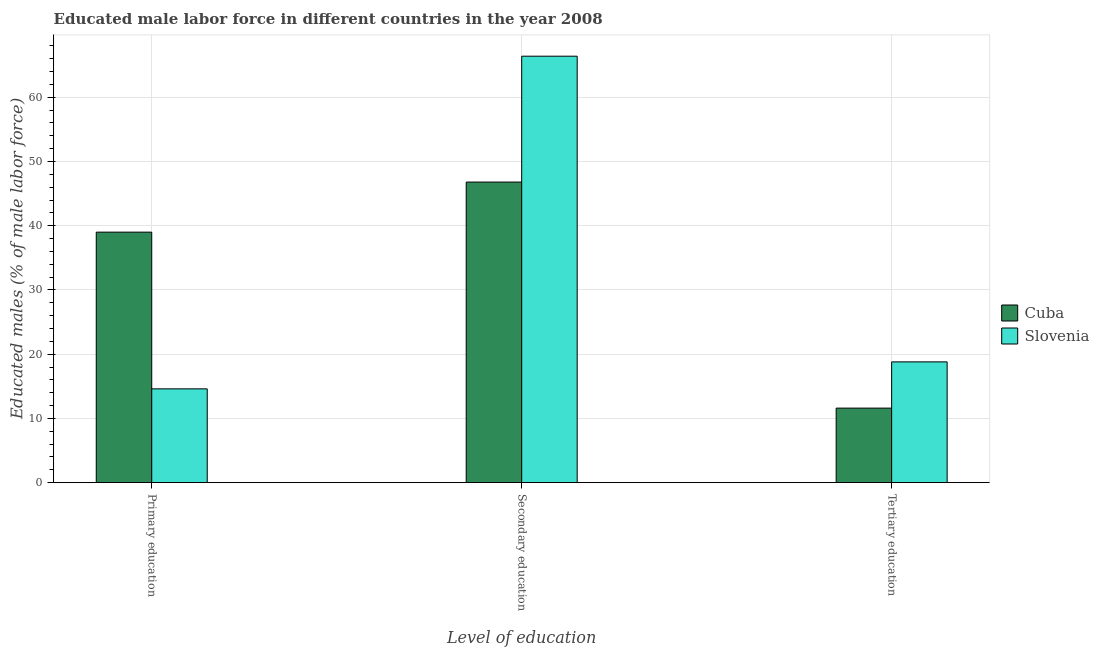How many different coloured bars are there?
Provide a succinct answer. 2. Are the number of bars on each tick of the X-axis equal?
Provide a short and direct response. Yes. How many bars are there on the 2nd tick from the left?
Provide a succinct answer. 2. What is the label of the 1st group of bars from the left?
Offer a very short reply. Primary education. What is the percentage of male labor force who received tertiary education in Cuba?
Give a very brief answer. 11.6. Across all countries, what is the maximum percentage of male labor force who received secondary education?
Make the answer very short. 66.4. Across all countries, what is the minimum percentage of male labor force who received primary education?
Keep it short and to the point. 14.6. In which country was the percentage of male labor force who received tertiary education maximum?
Provide a succinct answer. Slovenia. In which country was the percentage of male labor force who received secondary education minimum?
Provide a short and direct response. Cuba. What is the total percentage of male labor force who received tertiary education in the graph?
Give a very brief answer. 30.4. What is the difference between the percentage of male labor force who received tertiary education in Slovenia and that in Cuba?
Give a very brief answer. 7.2. What is the difference between the percentage of male labor force who received primary education in Slovenia and the percentage of male labor force who received secondary education in Cuba?
Your answer should be very brief. -32.2. What is the average percentage of male labor force who received secondary education per country?
Make the answer very short. 56.6. What is the difference between the percentage of male labor force who received secondary education and percentage of male labor force who received primary education in Cuba?
Your response must be concise. 7.8. What is the ratio of the percentage of male labor force who received secondary education in Slovenia to that in Cuba?
Your answer should be compact. 1.42. Is the percentage of male labor force who received secondary education in Slovenia less than that in Cuba?
Your answer should be very brief. No. What is the difference between the highest and the second highest percentage of male labor force who received secondary education?
Ensure brevity in your answer.  19.6. What is the difference between the highest and the lowest percentage of male labor force who received secondary education?
Keep it short and to the point. 19.6. Is the sum of the percentage of male labor force who received secondary education in Cuba and Slovenia greater than the maximum percentage of male labor force who received tertiary education across all countries?
Your answer should be compact. Yes. What does the 1st bar from the left in Tertiary education represents?
Your answer should be very brief. Cuba. What does the 2nd bar from the right in Tertiary education represents?
Give a very brief answer. Cuba. Is it the case that in every country, the sum of the percentage of male labor force who received primary education and percentage of male labor force who received secondary education is greater than the percentage of male labor force who received tertiary education?
Make the answer very short. Yes. Are all the bars in the graph horizontal?
Your response must be concise. No. How many countries are there in the graph?
Keep it short and to the point. 2. What is the difference between two consecutive major ticks on the Y-axis?
Ensure brevity in your answer.  10. Where does the legend appear in the graph?
Provide a short and direct response. Center right. How are the legend labels stacked?
Your response must be concise. Vertical. What is the title of the graph?
Your response must be concise. Educated male labor force in different countries in the year 2008. What is the label or title of the X-axis?
Provide a short and direct response. Level of education. What is the label or title of the Y-axis?
Ensure brevity in your answer.  Educated males (% of male labor force). What is the Educated males (% of male labor force) in Slovenia in Primary education?
Provide a short and direct response. 14.6. What is the Educated males (% of male labor force) in Cuba in Secondary education?
Offer a terse response. 46.8. What is the Educated males (% of male labor force) of Slovenia in Secondary education?
Offer a terse response. 66.4. What is the Educated males (% of male labor force) of Cuba in Tertiary education?
Offer a very short reply. 11.6. What is the Educated males (% of male labor force) in Slovenia in Tertiary education?
Provide a succinct answer. 18.8. Across all Level of education, what is the maximum Educated males (% of male labor force) in Cuba?
Ensure brevity in your answer.  46.8. Across all Level of education, what is the maximum Educated males (% of male labor force) in Slovenia?
Your answer should be compact. 66.4. Across all Level of education, what is the minimum Educated males (% of male labor force) in Cuba?
Ensure brevity in your answer.  11.6. Across all Level of education, what is the minimum Educated males (% of male labor force) of Slovenia?
Your answer should be compact. 14.6. What is the total Educated males (% of male labor force) in Cuba in the graph?
Make the answer very short. 97.4. What is the total Educated males (% of male labor force) of Slovenia in the graph?
Provide a succinct answer. 99.8. What is the difference between the Educated males (% of male labor force) in Slovenia in Primary education and that in Secondary education?
Offer a terse response. -51.8. What is the difference between the Educated males (% of male labor force) of Cuba in Primary education and that in Tertiary education?
Your response must be concise. 27.4. What is the difference between the Educated males (% of male labor force) of Cuba in Secondary education and that in Tertiary education?
Give a very brief answer. 35.2. What is the difference between the Educated males (% of male labor force) in Slovenia in Secondary education and that in Tertiary education?
Make the answer very short. 47.6. What is the difference between the Educated males (% of male labor force) in Cuba in Primary education and the Educated males (% of male labor force) in Slovenia in Secondary education?
Your answer should be very brief. -27.4. What is the difference between the Educated males (% of male labor force) in Cuba in Primary education and the Educated males (% of male labor force) in Slovenia in Tertiary education?
Offer a very short reply. 20.2. What is the difference between the Educated males (% of male labor force) of Cuba in Secondary education and the Educated males (% of male labor force) of Slovenia in Tertiary education?
Provide a short and direct response. 28. What is the average Educated males (% of male labor force) in Cuba per Level of education?
Give a very brief answer. 32.47. What is the average Educated males (% of male labor force) of Slovenia per Level of education?
Offer a terse response. 33.27. What is the difference between the Educated males (% of male labor force) in Cuba and Educated males (% of male labor force) in Slovenia in Primary education?
Ensure brevity in your answer.  24.4. What is the difference between the Educated males (% of male labor force) of Cuba and Educated males (% of male labor force) of Slovenia in Secondary education?
Your response must be concise. -19.6. What is the difference between the Educated males (% of male labor force) of Cuba and Educated males (% of male labor force) of Slovenia in Tertiary education?
Offer a very short reply. -7.2. What is the ratio of the Educated males (% of male labor force) in Slovenia in Primary education to that in Secondary education?
Give a very brief answer. 0.22. What is the ratio of the Educated males (% of male labor force) in Cuba in Primary education to that in Tertiary education?
Offer a very short reply. 3.36. What is the ratio of the Educated males (% of male labor force) in Slovenia in Primary education to that in Tertiary education?
Offer a terse response. 0.78. What is the ratio of the Educated males (% of male labor force) of Cuba in Secondary education to that in Tertiary education?
Give a very brief answer. 4.03. What is the ratio of the Educated males (% of male labor force) in Slovenia in Secondary education to that in Tertiary education?
Offer a terse response. 3.53. What is the difference between the highest and the second highest Educated males (% of male labor force) in Slovenia?
Offer a very short reply. 47.6. What is the difference between the highest and the lowest Educated males (% of male labor force) of Cuba?
Your response must be concise. 35.2. What is the difference between the highest and the lowest Educated males (% of male labor force) of Slovenia?
Offer a terse response. 51.8. 